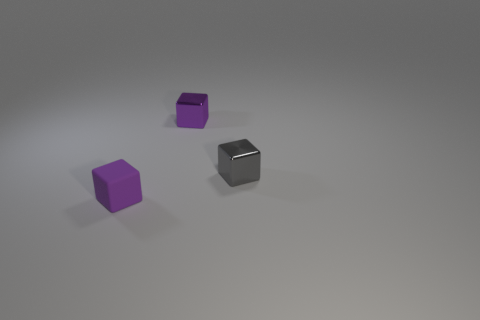Do the metallic cube that is left of the small gray metallic cube and the rubber cube have the same color?
Make the answer very short. Yes. The other object that is the same color as the tiny rubber object is what shape?
Your response must be concise. Cube. What color is the matte block that is the same size as the gray metallic cube?
Your answer should be very brief. Purple. Are there any small metal objects of the same color as the rubber cube?
Give a very brief answer. Yes. What is the gray object made of?
Your response must be concise. Metal. What number of big cyan blocks are there?
Give a very brief answer. 0. Is the color of the block behind the small gray metallic block the same as the rubber thing that is on the left side of the tiny gray object?
Make the answer very short. Yes. There is a small rubber block that is in front of the small purple metallic cube; what is its color?
Your answer should be compact. Purple. Are the small object in front of the gray shiny block and the small gray cube made of the same material?
Keep it short and to the point. No. What number of cubes are on the left side of the gray metallic object and in front of the small purple metallic thing?
Offer a terse response. 1. 